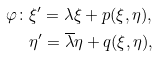<formula> <loc_0><loc_0><loc_500><loc_500>\varphi \colon & \xi ^ { \prime } = \lambda \xi + p ( \xi , \eta ) , \\ & \eta ^ { \prime } = \overline { \lambda } \eta + q ( \xi , \eta ) ,</formula> 